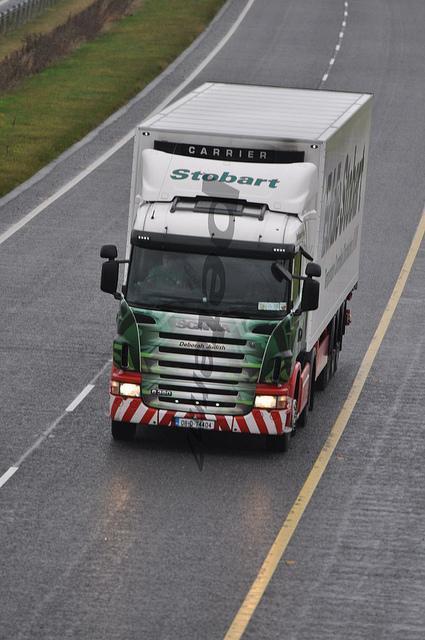How many vehicles are there?
Give a very brief answer. 1. How many giraffe are there?
Give a very brief answer. 0. 